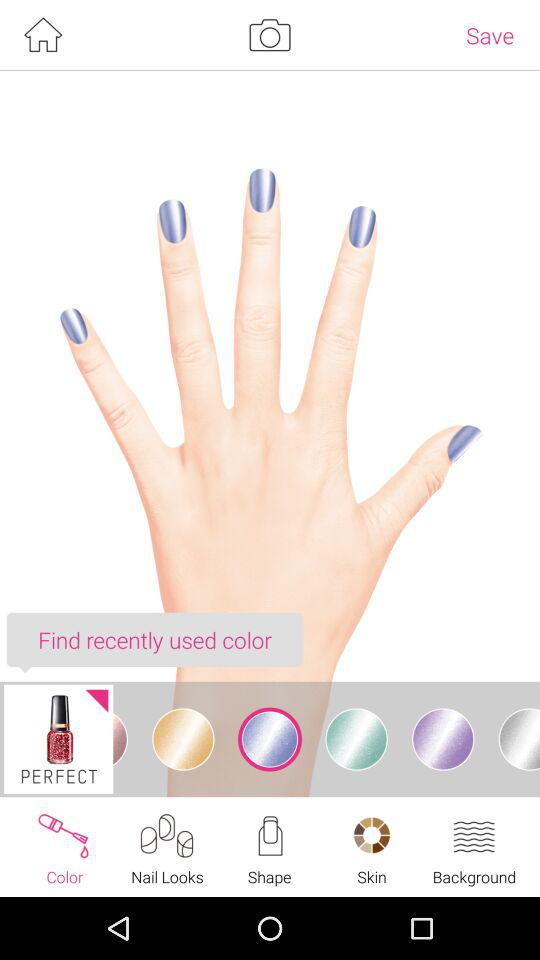Which tab is selected? The selected tab is "Color". 